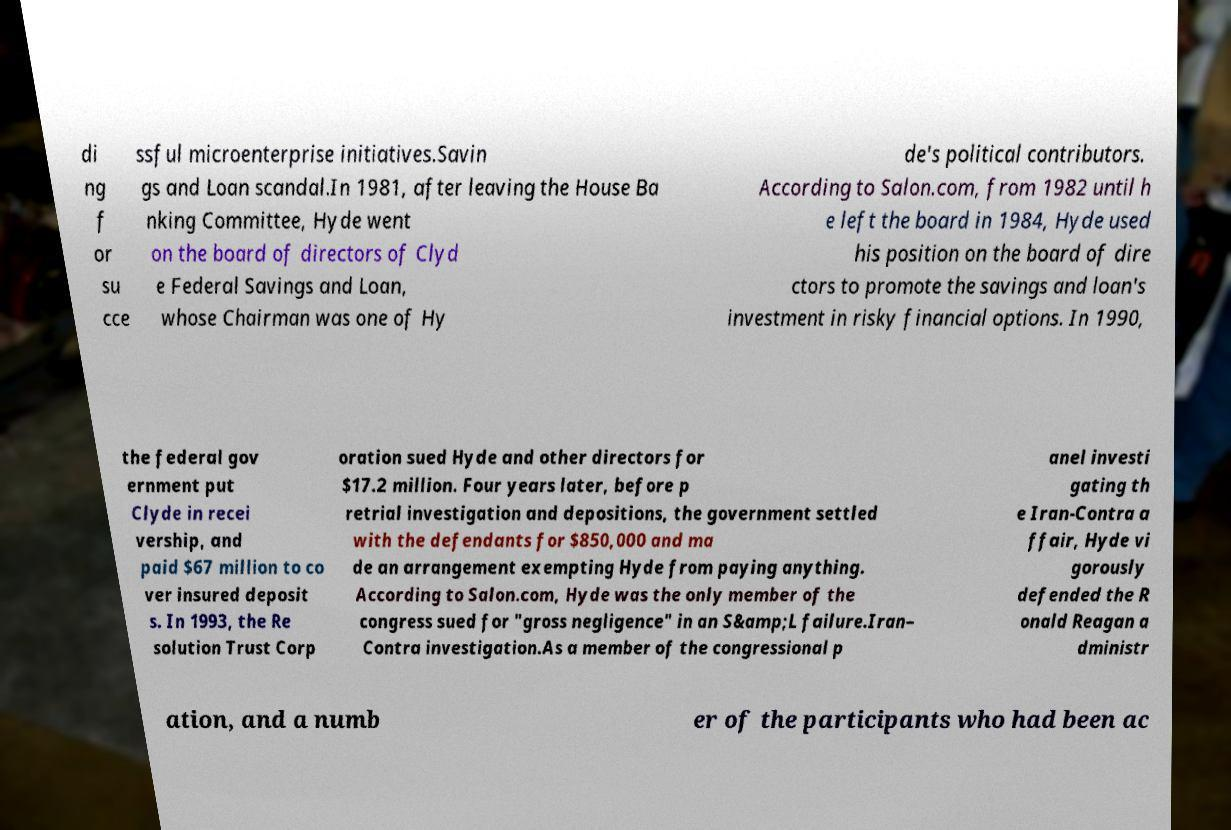What messages or text are displayed in this image? I need them in a readable, typed format. di ng f or su cce ssful microenterprise initiatives.Savin gs and Loan scandal.In 1981, after leaving the House Ba nking Committee, Hyde went on the board of directors of Clyd e Federal Savings and Loan, whose Chairman was one of Hy de's political contributors. According to Salon.com, from 1982 until h e left the board in 1984, Hyde used his position on the board of dire ctors to promote the savings and loan's investment in risky financial options. In 1990, the federal gov ernment put Clyde in recei vership, and paid $67 million to co ver insured deposit s. In 1993, the Re solution Trust Corp oration sued Hyde and other directors for $17.2 million. Four years later, before p retrial investigation and depositions, the government settled with the defendants for $850,000 and ma de an arrangement exempting Hyde from paying anything. According to Salon.com, Hyde was the only member of the congress sued for "gross negligence" in an S&amp;L failure.Iran– Contra investigation.As a member of the congressional p anel investi gating th e Iran-Contra a ffair, Hyde vi gorously defended the R onald Reagan a dministr ation, and a numb er of the participants who had been ac 